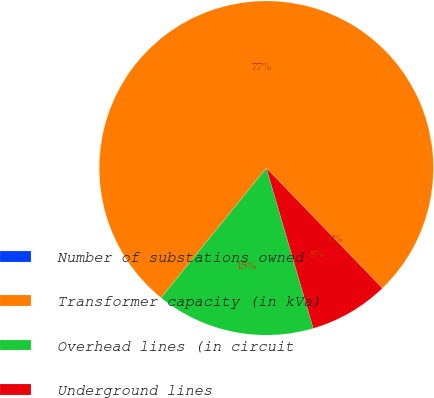Convert chart to OTSL. <chart><loc_0><loc_0><loc_500><loc_500><pie_chart><fcel>Number of substations owned<fcel>Transformer capacity (in kVa)<fcel>Overhead lines (in circuit<fcel>Underground lines<nl><fcel>0.0%<fcel>76.92%<fcel>15.38%<fcel>7.69%<nl></chart> 